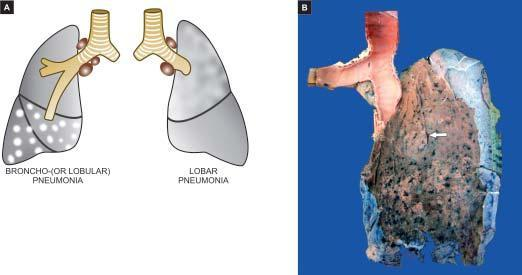what shows serofibrinous exudate?
Answer the question using a single word or phrase. Pleural surface of the specimen of the lung 